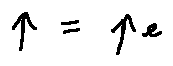<formula> <loc_0><loc_0><loc_500><loc_500>p = p _ { e }</formula> 